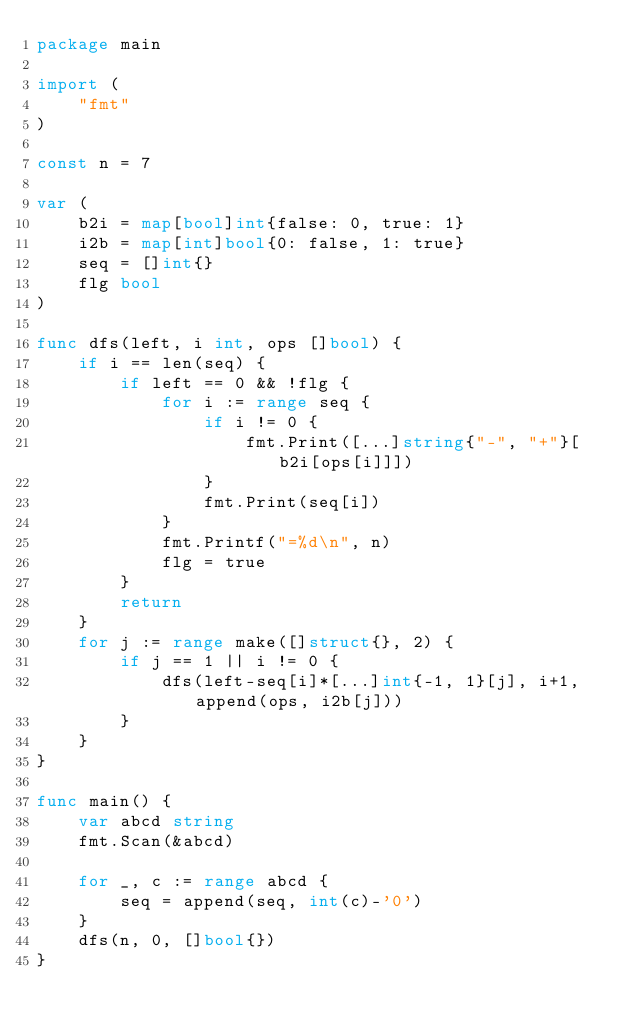Convert code to text. <code><loc_0><loc_0><loc_500><loc_500><_Go_>package main

import (
	"fmt"
)

const n = 7

var (
	b2i = map[bool]int{false: 0, true: 1}
	i2b = map[int]bool{0: false, 1: true}
	seq = []int{}
	flg bool
)

func dfs(left, i int, ops []bool) {
	if i == len(seq) {
		if left == 0 && !flg {
			for i := range seq {
				if i != 0 {
					fmt.Print([...]string{"-", "+"}[b2i[ops[i]]])
				}
				fmt.Print(seq[i])
			}
			fmt.Printf("=%d\n", n)
			flg = true
		}
		return
	}
	for j := range make([]struct{}, 2) {
		if j == 1 || i != 0 {
			dfs(left-seq[i]*[...]int{-1, 1}[j], i+1, append(ops, i2b[j]))
		}
	}
}

func main() {
	var abcd string
	fmt.Scan(&abcd)

	for _, c := range abcd {
		seq = append(seq, int(c)-'0')
	}
	dfs(n, 0, []bool{})
}
</code> 